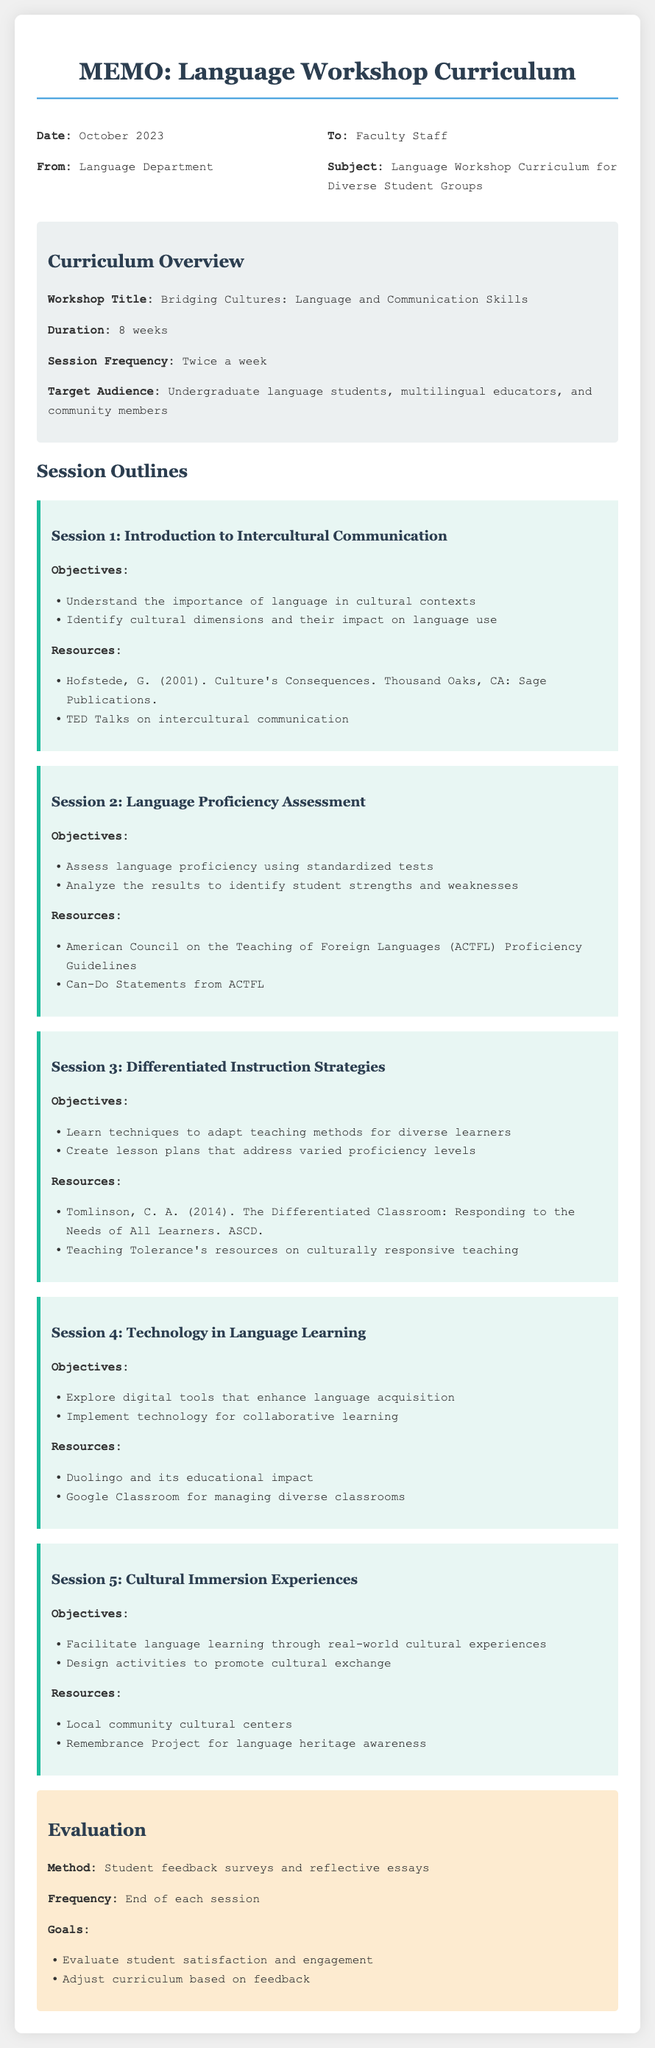What is the workshop title? The workshop title is explicitly stated in the curriculum overview section of the document.
Answer: Bridging Cultures: Language and Communication Skills What is the duration of the workshop? The duration is specified in the curriculum overview section.
Answer: 8 weeks How often are the sessions held? The frequency of the sessions is mentioned in the curriculum overview.
Answer: Twice a week What is the target audience for the workshop? The target audience is listed in the curriculum overview, detailing who the workshop is designed for.
Answer: Undergraduate language students, multilingual educators, and community members What is the objective of Session 2? The objectives for each session are outlined, and this specific session focuses on language proficiency assessment.
Answer: Assess language proficiency using standardized tests What resource is suggested for Session 3? Each session lists specific resources, and for Session 3, a prominent resource is provided.
Answer: Tomlinson, C. A. (2014). The Differentiated Classroom: Responding to the Needs of All Learners. ASCD What type of feedback is used for evaluation? The evaluation method to be used is mentioned under the evaluation section of the document.
Answer: Student feedback surveys and reflective essays How frequently is feedback collected? The frequency of the feedback collection is included in the evaluation section.
Answer: End of each session What are the goals of the evaluation? The goals are explicitly listed in the evaluation section, detailing what the evaluation aims to achieve.
Answer: Evaluate student satisfaction and engagement 